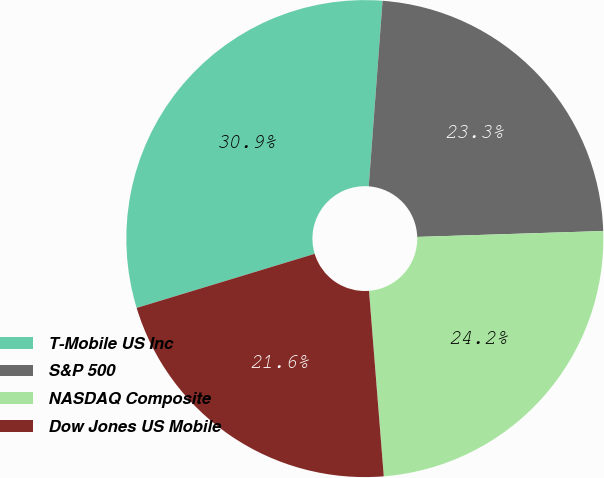Convert chart. <chart><loc_0><loc_0><loc_500><loc_500><pie_chart><fcel>T-Mobile US Inc<fcel>S&P 500<fcel>NASDAQ Composite<fcel>Dow Jones US Mobile<nl><fcel>30.88%<fcel>23.31%<fcel>24.24%<fcel>21.57%<nl></chart> 